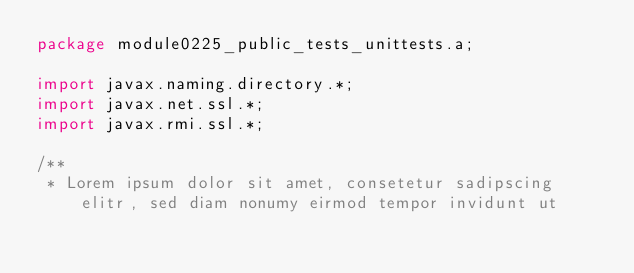<code> <loc_0><loc_0><loc_500><loc_500><_Java_>package module0225_public_tests_unittests.a;

import javax.naming.directory.*;
import javax.net.ssl.*;
import javax.rmi.ssl.*;

/**
 * Lorem ipsum dolor sit amet, consetetur sadipscing elitr, sed diam nonumy eirmod tempor invidunt ut </code> 